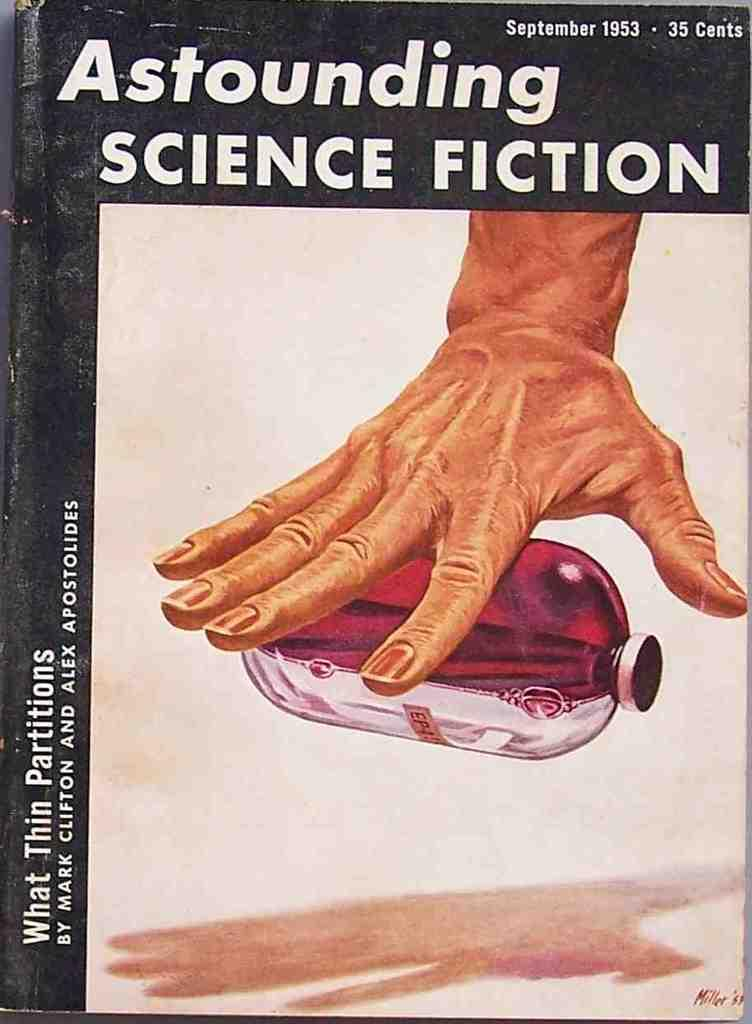Provide a one-sentence caption for the provided image. a book from 1953 called astounding science fiction has a picture of a hand on it. 